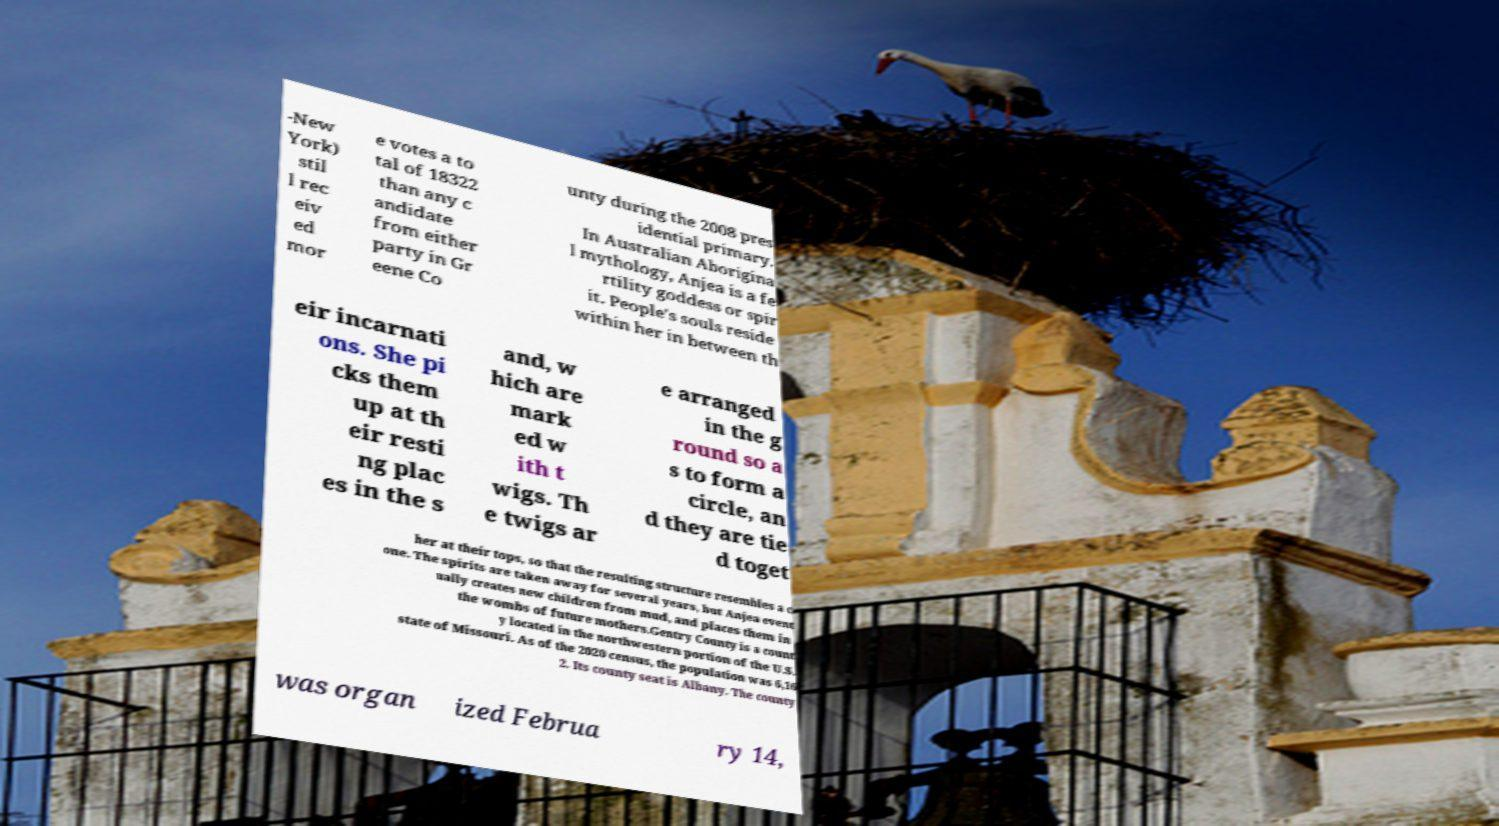Please read and relay the text visible in this image. What does it say? -New York) stil l rec eiv ed mor e votes a to tal of 18322 than any c andidate from either party in Gr eene Co unty during the 2008 pres idential primary. In Australian Aborigina l mythology, Anjea is a fe rtility goddess or spir it. People's souls reside within her in between th eir incarnati ons. She pi cks them up at th eir resti ng plac es in the s and, w hich are mark ed w ith t wigs. Th e twigs ar e arranged in the g round so a s to form a circle, an d they are tie d toget her at their tops, so that the resulting structure resembles a c one. The spirits are taken away for several years, but Anjea event ually creates new children from mud, and places them in the wombs of future mothers.Gentry County is a count y located in the northwestern portion of the U.S. state of Missouri. As of the 2020 census, the population was 6,16 2. Its county seat is Albany. The county was organ ized Februa ry 14, 